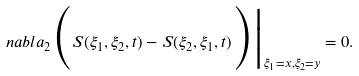<formula> <loc_0><loc_0><loc_500><loc_500>n a b l a _ { 2 } \Big ( S ( \xi _ { 1 } , \xi _ { 2 } , t ) - S ( \xi _ { 2 } , \xi _ { 1 } , t ) \Big ) \Big | _ { \xi _ { 1 } = { x } , \xi _ { 2 } = { y } } = 0 .</formula> 